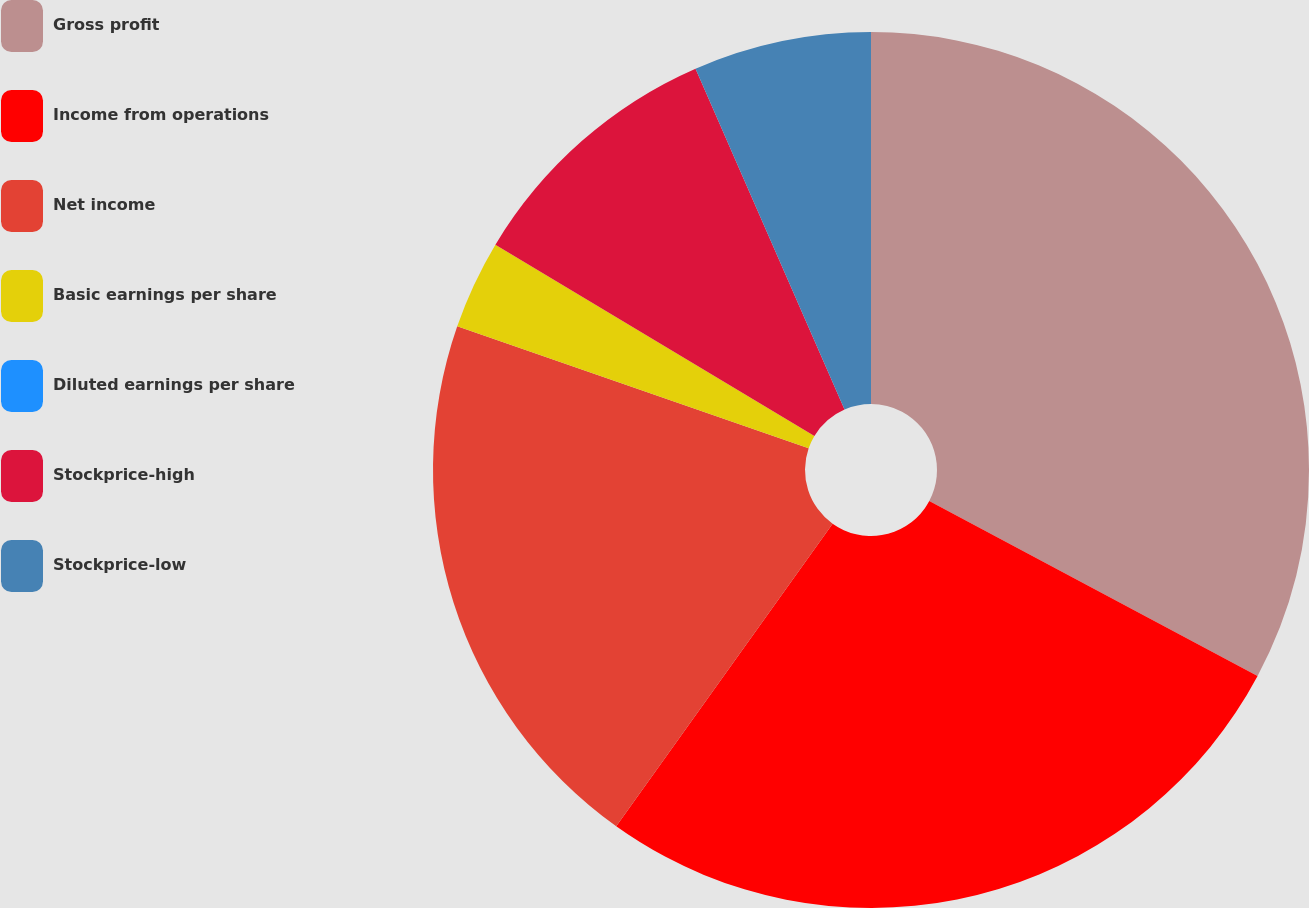<chart> <loc_0><loc_0><loc_500><loc_500><pie_chart><fcel>Gross profit<fcel>Income from operations<fcel>Net income<fcel>Basic earnings per share<fcel>Diluted earnings per share<fcel>Stockprice-high<fcel>Stockprice-low<nl><fcel>32.79%<fcel>27.09%<fcel>20.44%<fcel>3.28%<fcel>0.0%<fcel>9.84%<fcel>6.56%<nl></chart> 